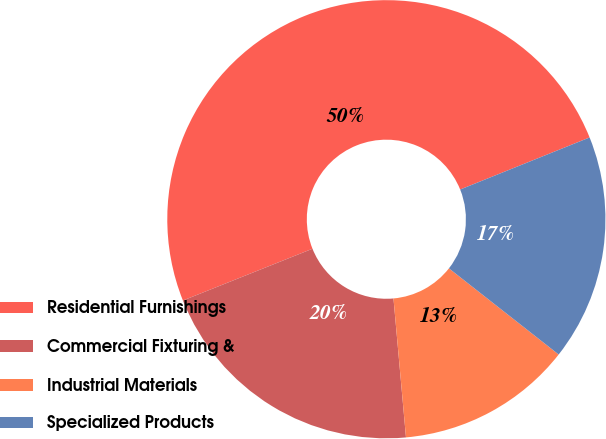Convert chart to OTSL. <chart><loc_0><loc_0><loc_500><loc_500><pie_chart><fcel>Residential Furnishings<fcel>Commercial Fixturing &<fcel>Industrial Materials<fcel>Specialized Products<nl><fcel>49.97%<fcel>20.38%<fcel>12.98%<fcel>16.68%<nl></chart> 